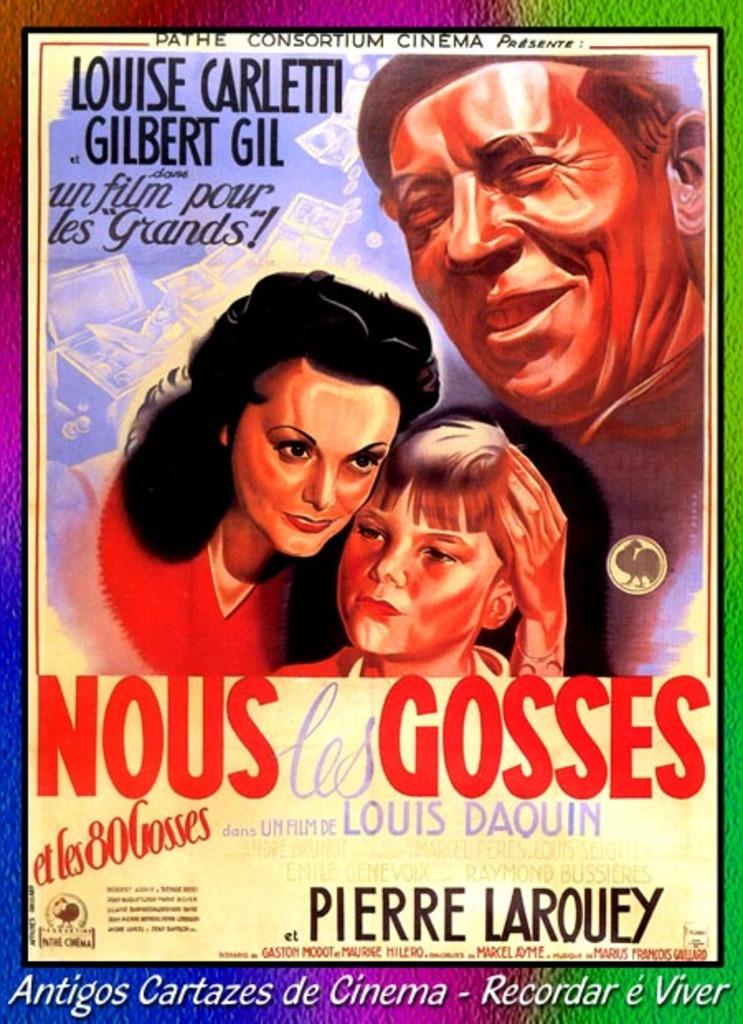<image>
Summarize the visual content of the image. A poster for Nous Les Gosses by Pierre Larouey is playing at the Pathe Consortium Cinema 